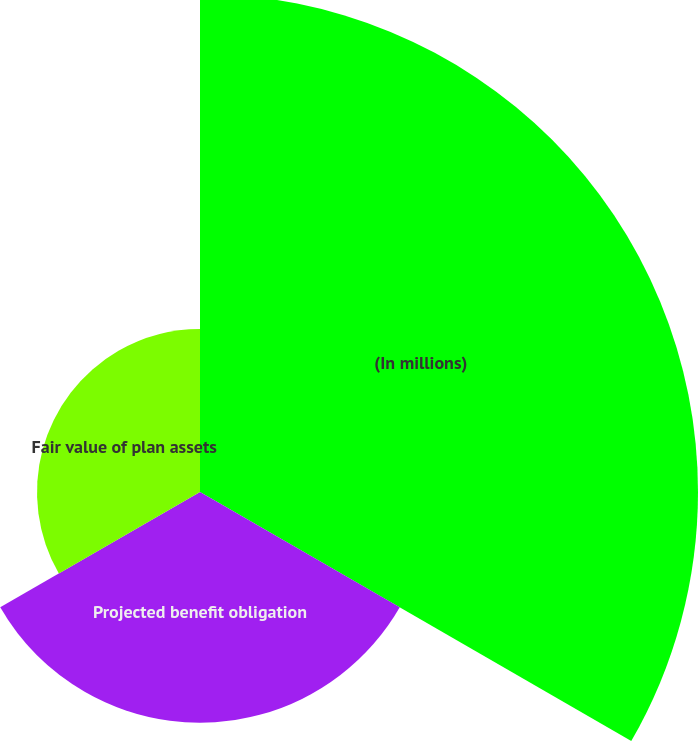Convert chart. <chart><loc_0><loc_0><loc_500><loc_500><pie_chart><fcel>(In millions)<fcel>Projected benefit obligation<fcel>Fair value of plan assets<nl><fcel>55.85%<fcel>25.87%<fcel>18.28%<nl></chart> 